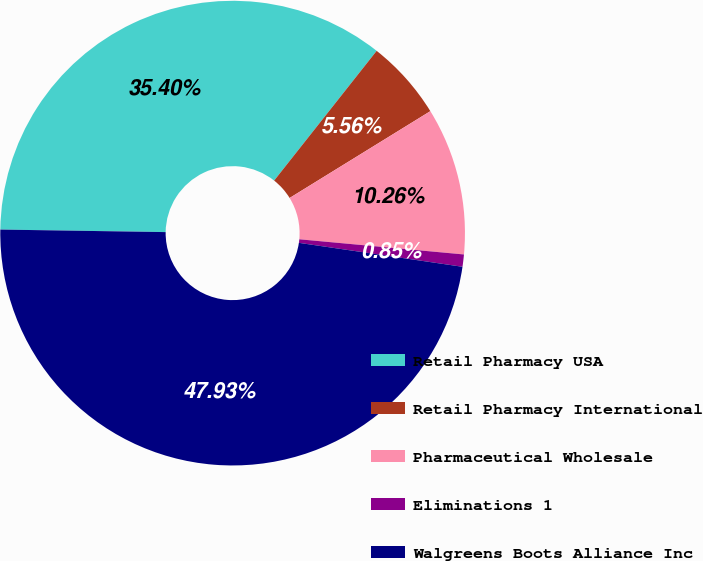<chart> <loc_0><loc_0><loc_500><loc_500><pie_chart><fcel>Retail Pharmacy USA<fcel>Retail Pharmacy International<fcel>Pharmaceutical Wholesale<fcel>Eliminations 1<fcel>Walgreens Boots Alliance Inc<nl><fcel>35.4%<fcel>5.56%<fcel>10.26%<fcel>0.85%<fcel>47.93%<nl></chart> 